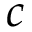<formula> <loc_0><loc_0><loc_500><loc_500>c</formula> 